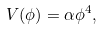Convert formula to latex. <formula><loc_0><loc_0><loc_500><loc_500>V ( \phi ) = \alpha \phi ^ { 4 } ,</formula> 